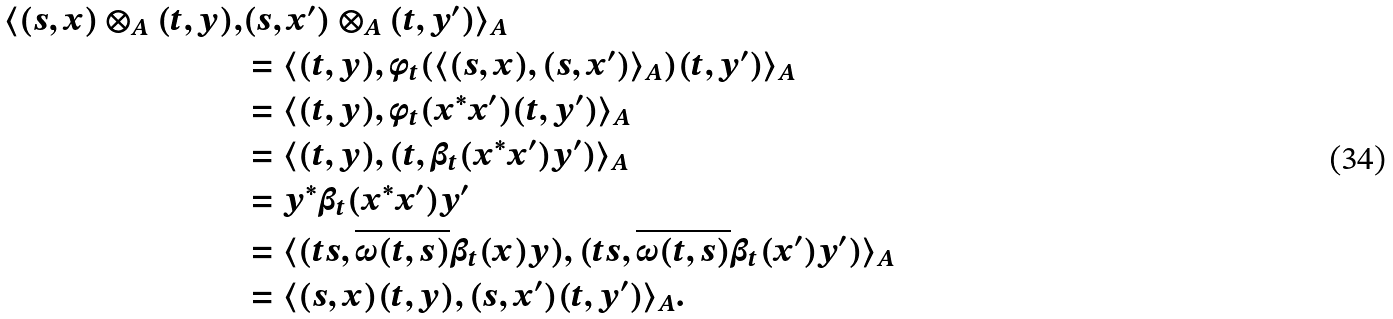Convert formula to latex. <formula><loc_0><loc_0><loc_500><loc_500>\langle ( s , x ) \otimes _ { A } ( t , y ) , & ( s , x ^ { \prime } ) \otimes _ { A } ( t , y ^ { \prime } ) \rangle _ { A } \\ & = \langle ( t , y ) , \phi _ { t } ( \langle ( s , x ) , ( s , x ^ { \prime } ) \rangle _ { A } ) ( t , y ^ { \prime } ) \rangle _ { A } \\ & = \langle ( t , y ) , \phi _ { t } ( x ^ { * } x ^ { \prime } ) ( t , y ^ { \prime } ) \rangle _ { A } \\ & = \langle ( t , y ) , ( t , \beta _ { t } ( x ^ { * } x ^ { \prime } ) y ^ { \prime } ) \rangle _ { A } \\ & = y ^ { * } \beta _ { t } ( x ^ { * } x ^ { \prime } ) y ^ { \prime } \\ & = \langle ( t s , \overline { \omega ( t , s ) } \beta _ { t } ( x ) y ) , ( t s , \overline { \omega ( t , s ) } \beta _ { t } ( x ^ { \prime } ) y ^ { \prime } ) \rangle _ { A } \\ & = \langle ( s , x ) ( t , y ) , ( s , x ^ { \prime } ) ( t , y ^ { \prime } ) \rangle _ { A } .</formula> 